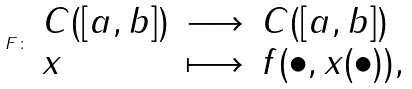Convert formula to latex. <formula><loc_0><loc_0><loc_500><loc_500>\ F \colon \left . \begin{array} { l l l } C ( [ a , b ] ) & \longrightarrow & C ( [ a , b ] ) \\ x & \longmapsto & f ( \bullet , x ( \bullet ) ) , \end{array} \right .</formula> 